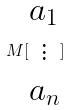<formula> <loc_0><loc_0><loc_500><loc_500>M [ \begin{matrix} a _ { 1 } \\ \vdots \\ a _ { n } \end{matrix} ]</formula> 